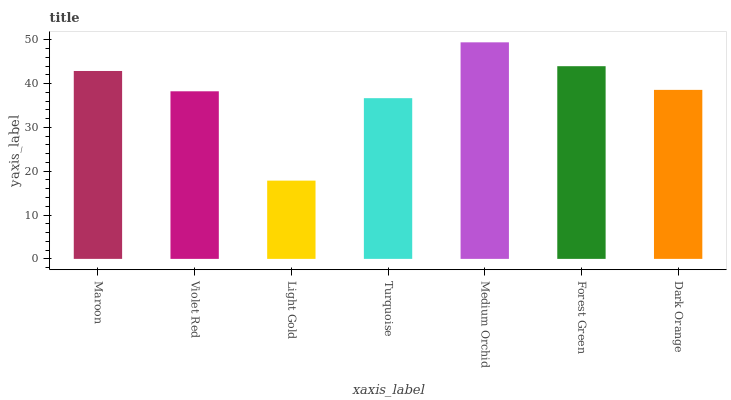Is Light Gold the minimum?
Answer yes or no. Yes. Is Medium Orchid the maximum?
Answer yes or no. Yes. Is Violet Red the minimum?
Answer yes or no. No. Is Violet Red the maximum?
Answer yes or no. No. Is Maroon greater than Violet Red?
Answer yes or no. Yes. Is Violet Red less than Maroon?
Answer yes or no. Yes. Is Violet Red greater than Maroon?
Answer yes or no. No. Is Maroon less than Violet Red?
Answer yes or no. No. Is Dark Orange the high median?
Answer yes or no. Yes. Is Dark Orange the low median?
Answer yes or no. Yes. Is Violet Red the high median?
Answer yes or no. No. Is Forest Green the low median?
Answer yes or no. No. 